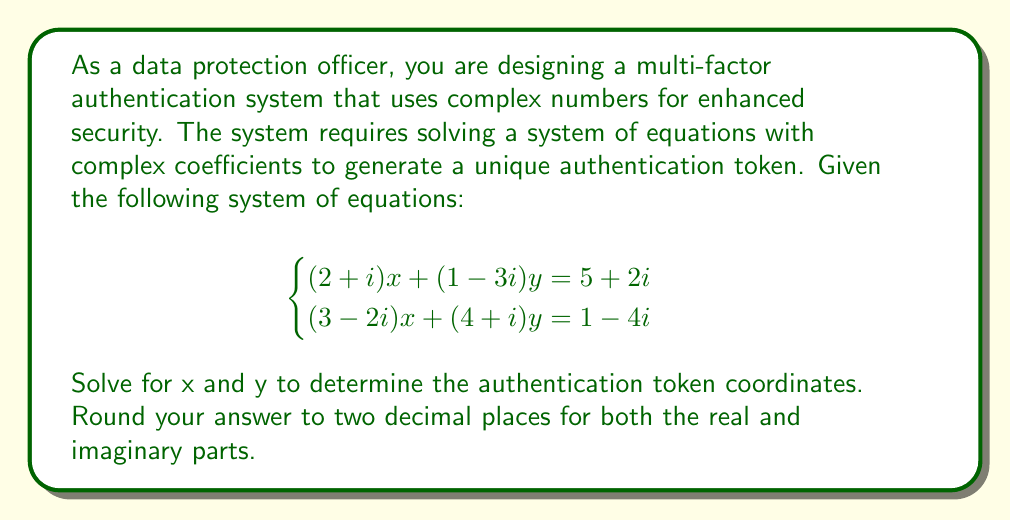Can you answer this question? To solve this system of equations with complex coefficients, we'll use the substitution method:

1) Let's express y in terms of x from the first equation:
   $$(2+i)x + (1-3i)y = 5+2i$$
   $$(1-3i)y = (5+2i) - (2+i)x$$
   $$y = \frac{(5+2i) - (2+i)x}{1-3i}$$

2) Multiply both numerator and denominator by the complex conjugate of the denominator (1+3i):
   $$y = \frac{((5+2i) - (2+i)x)(1+3i)}{(1-3i)(1+3i)} = \frac{((5+2i) - (2+i)x)(1+3i)}{10}$$

3) Expand the numerator:
   $$y = \frac{(5+2i)(1+3i) - (2+i)(1+3i)x}{10}$$
   $$y = \frac{(5+15i+2i-6) - (2+6i+i+3i^2)x}{10}$$
   $$y = \frac{(-1+17i) - (2+7i-3)x}{10}$$
   $$y = \frac{(-1+17i) - (5+7i)x}{10}$$

4) Substitute this expression for y into the second equation:
   $$(3-2i)x + (4+i)(\frac{(-1+17i) - (5+7i)x}{10}) = 1-4i$$

5) Multiply both sides by 10:
   $$10(3-2i)x + (4+i)((-1+17i) - (5+7i)x) = 10(1-4i)$$

6) Expand:
   $$(30-20i)x + (-4-i+68i+17) - (20+28i+5i+7i^2)x = 10-40i$$
   $$(30-20i)x + (13+67i) - (20+33i-7)x = 10-40i$$
   $$(30-20i)x - (20+33i-7)x = -3-107i$$
   $$(10-53i+7)x = -3-107i$$
   $$(17-53i)x = -3-107i$$

7) Multiply both sides by the complex conjugate of the coefficient of x:
   $$((17-53i)x)(17+53i) = (-3-107i)(17+53i)$$
   $$(17^2+53^2)x = (-3-107i)(17+53i)$$
   $$3098x = -51-1819i-1809i+5671$$
   $$3098x = 5620-3628i$$

8) Solve for x:
   $$x = \frac{5620-3628i}{3098} \approx 1.81 - 1.17i$$

9) Substitute this value of x back into the equation for y:
   $$y = \frac{(-1+17i) - (5+7i)(1.81-1.17i)}{10}$$
   $$y \approx 0.14 + 0.48i$$
Answer: The authentication token coordinates are:
x ≈ 1.81 - 1.17i
y ≈ 0.14 + 0.48i 